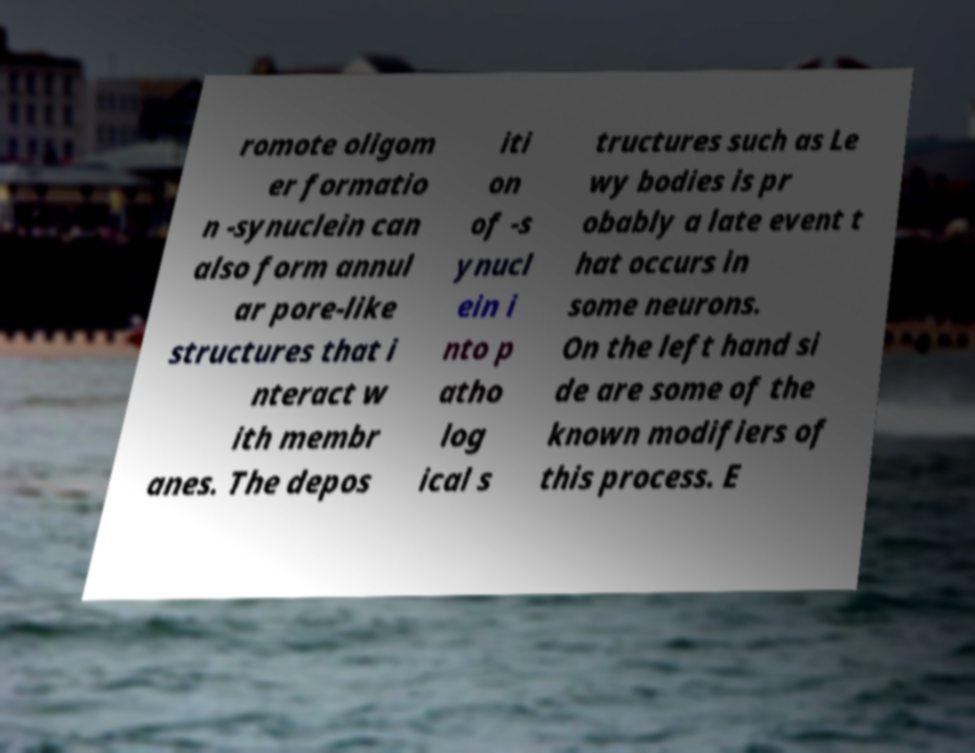Could you extract and type out the text from this image? romote oligom er formatio n -synuclein can also form annul ar pore-like structures that i nteract w ith membr anes. The depos iti on of -s ynucl ein i nto p atho log ical s tructures such as Le wy bodies is pr obably a late event t hat occurs in some neurons. On the left hand si de are some of the known modifiers of this process. E 